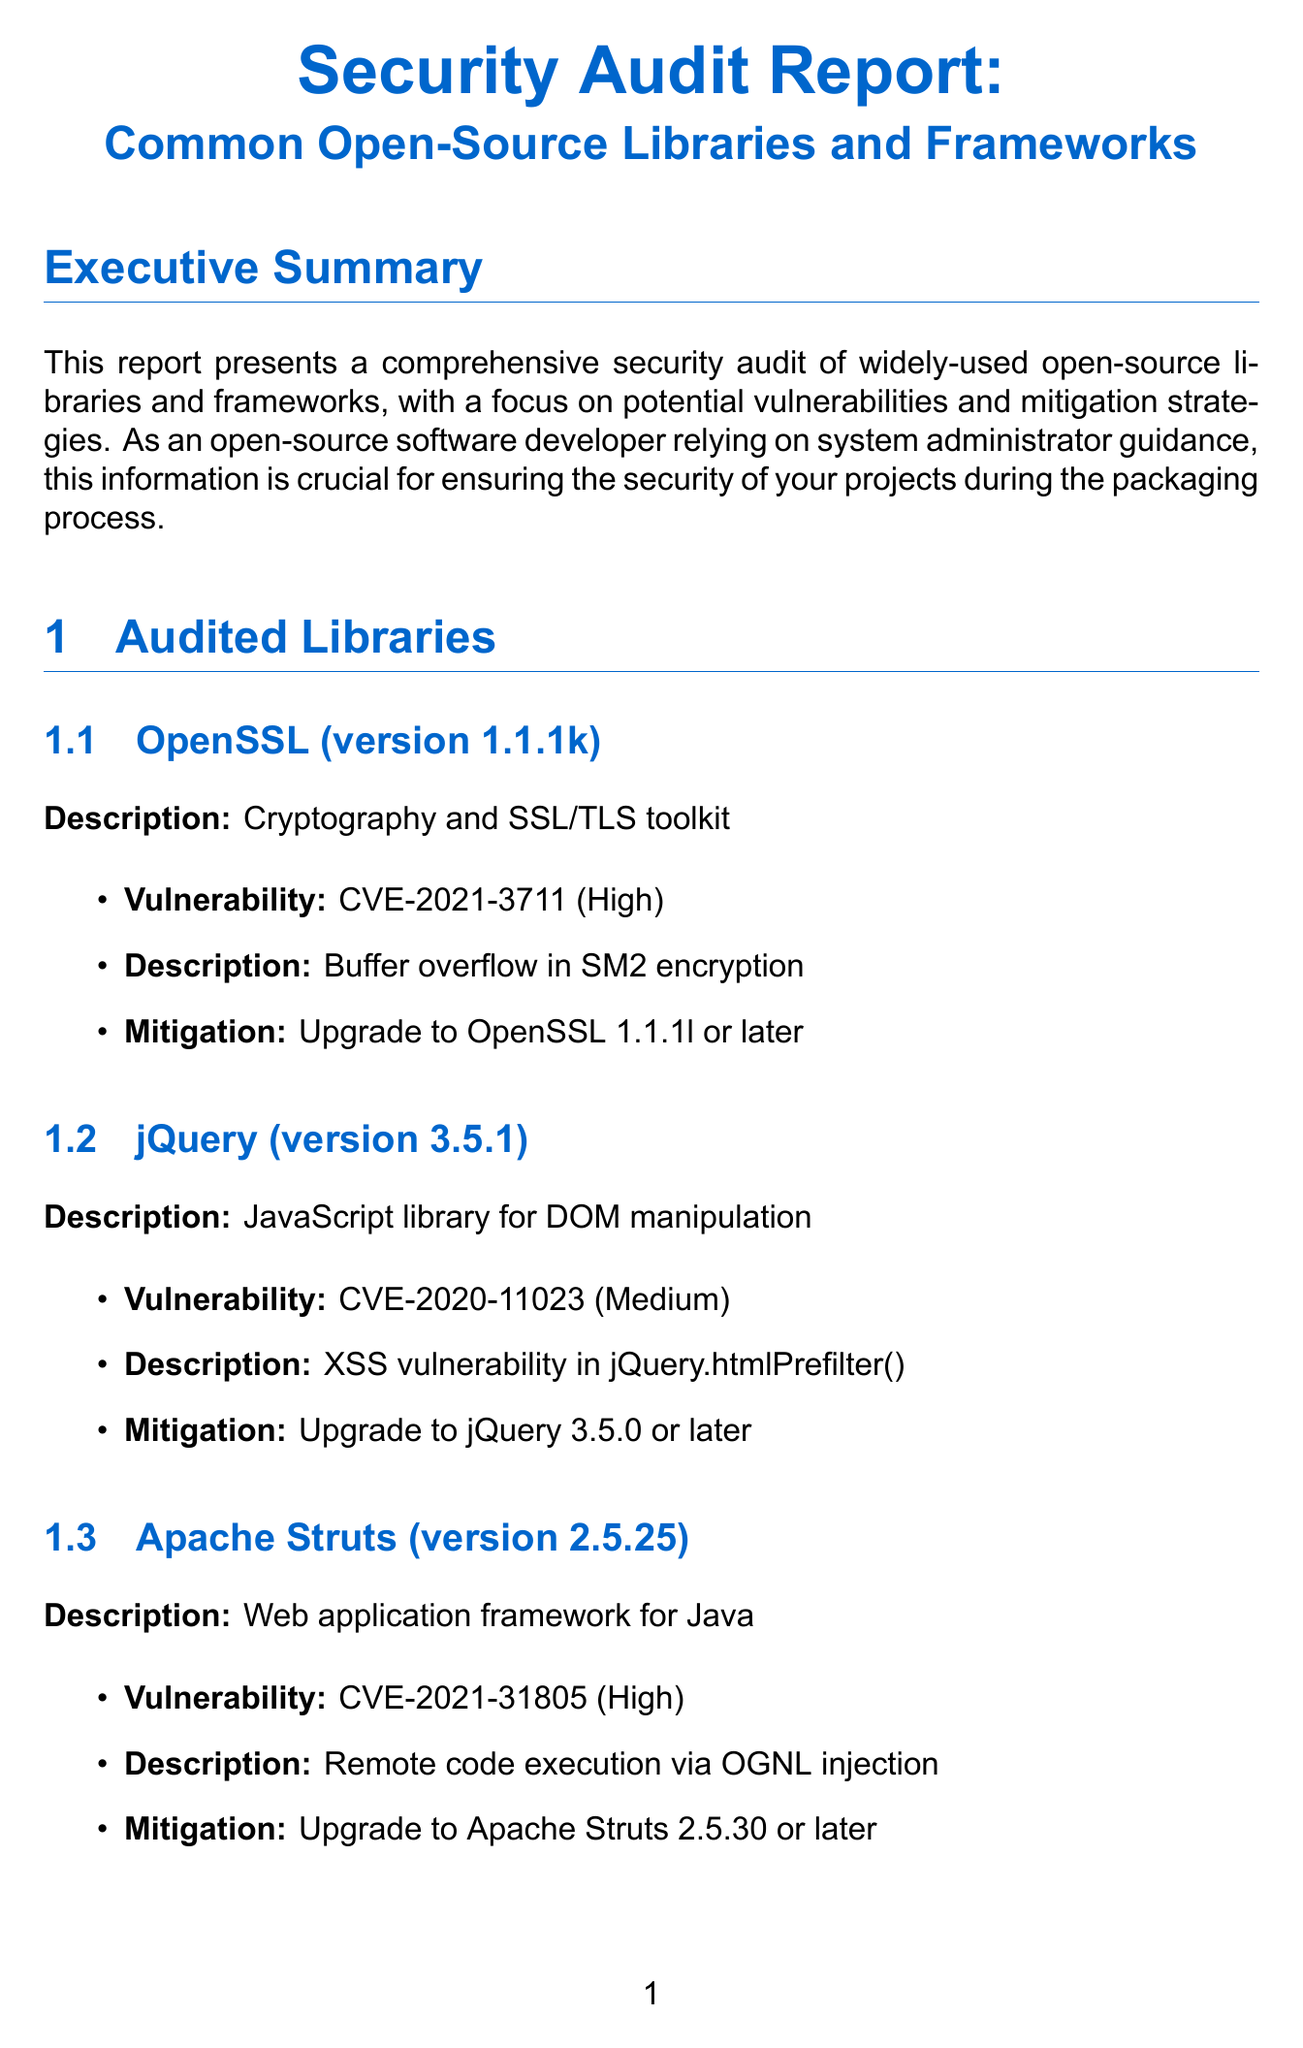What is the title of the report? The title of the report is explicitly stated at the beginning of the document.
Answer: Security Audit Report: Common Open-Source Libraries and Frameworks How many libraries were audited in this report? The document lists three libraries that were subject to the audit, identifying each one.
Answer: 3 What is the first general recommendation? The first item in the list of general recommendations reflects a key action suggested in the report.
Answer: Regularly update dependencies to their latest stable versions What is the CVE ID for the vulnerability in OpenSSL? The document specifies the vulnerability associated with OpenSSL and its unique identifier.
Answer: CVE-2021-3711 What is the severity level of the vulnerability in Apache Struts? The document provides a severity rating for the vulnerabilities associated with different libraries, including Apache Struts.
Answer: High Which best practice category includes input validation? The document groups security best practices into categories, specifying where input validation is mentioned.
Answer: Secure Coding What should be done before integrating new libraries? The document outlines a recommendation that addresses security measures related to library integration.
Answer: Discuss security implications of new libraries before integration What is the next step suggested for addressing identified vulnerabilities? The 'Next Steps' section of the document provides a series of actionable items, including one for vulnerabilities.
Answer: Develop an action plan for addressing identified vulnerabilities 